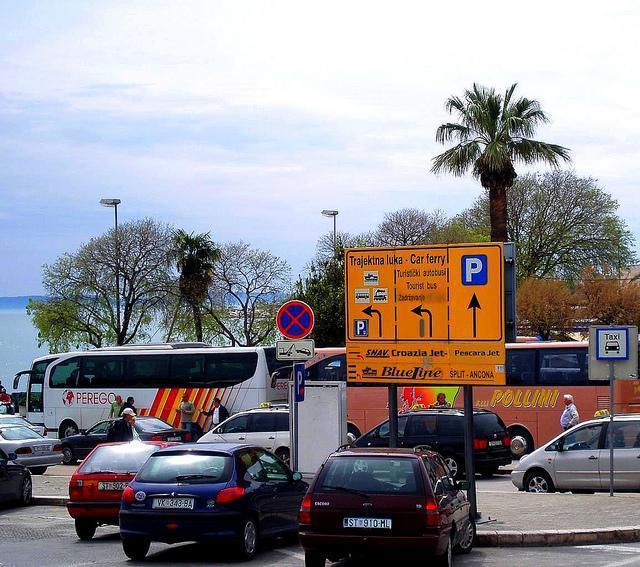How many cars are there?
Give a very brief answer. 8. How many buses are in the photo?
Give a very brief answer. 2. 